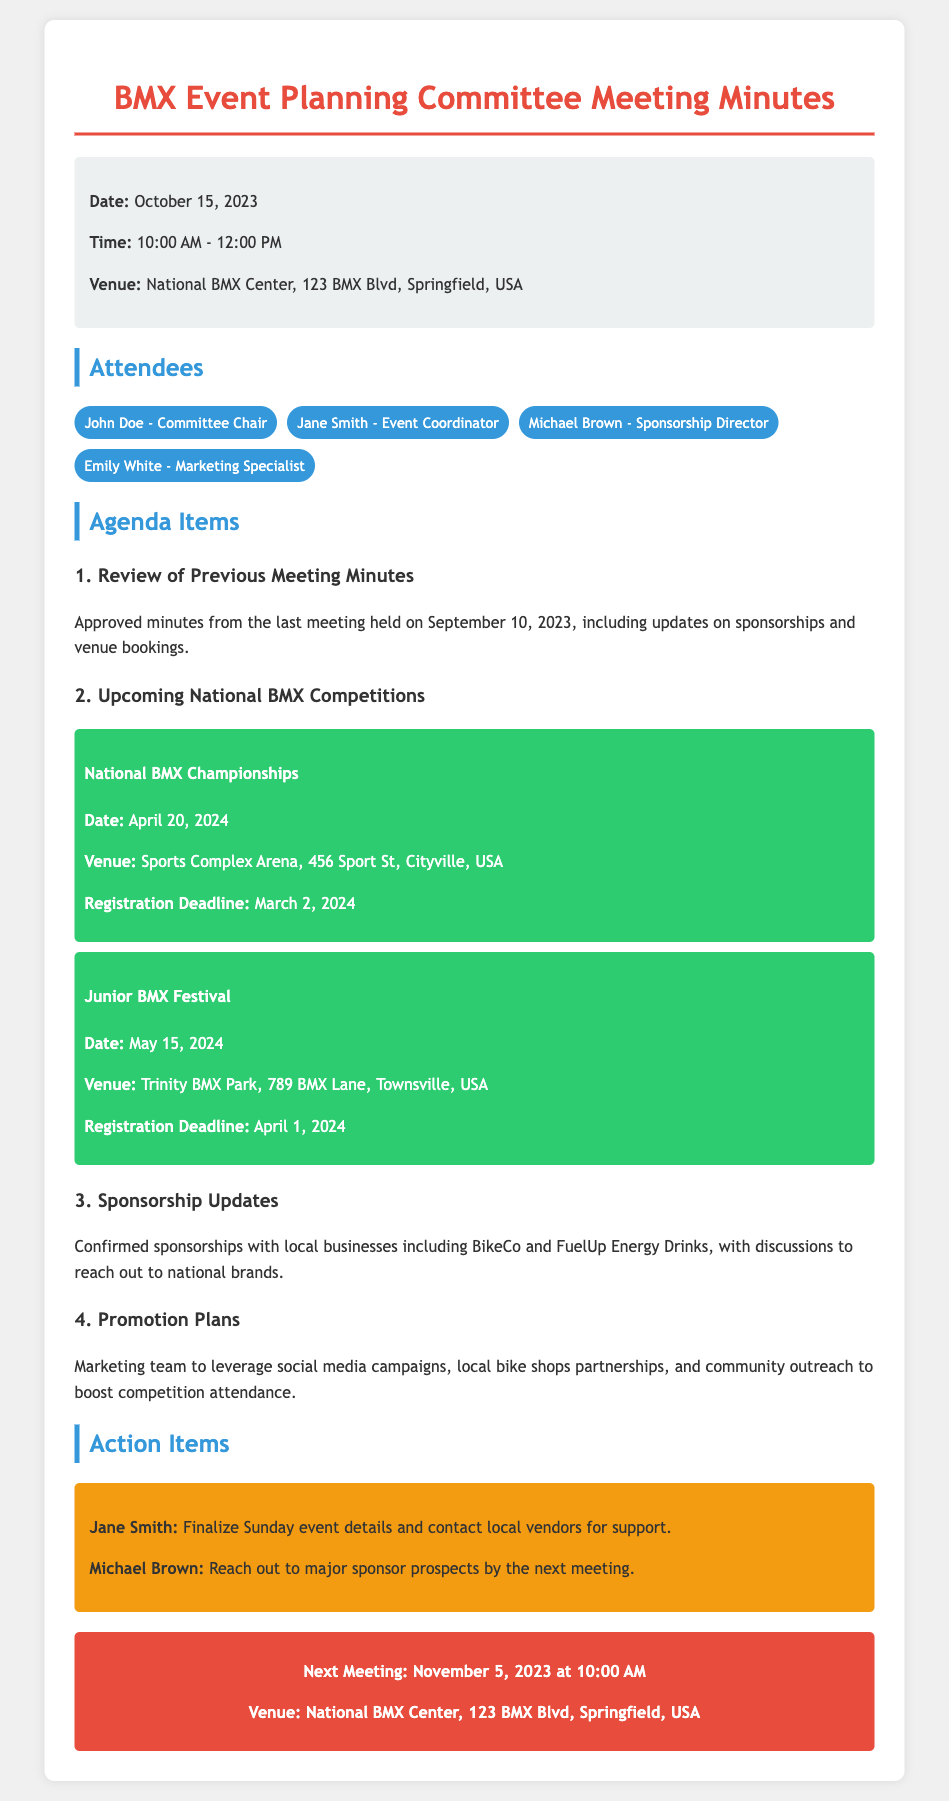what is the date of the next meeting? The next meeting date is listed under the next meeting section of the document.
Answer: November 5, 2023 where is the National BMX Championships held? The venue for the National BMX Championships is mentioned under the upcoming national BMX competitions section.
Answer: Sports Complex Arena, 456 Sport St, Cityville, USA who is the Committee Chair? The name of the Committee Chair is provided in the attendees section of the document.
Answer: John Doe what is the registration deadline for the Junior BMX Festival? The registration deadline is provided in the details of the Junior BMX Festival under the upcoming competitions.
Answer: April 1, 2024 how many attendees were present at the meeting? The number of attendees can be counted from the attendees section where their names are listed.
Answer: 4 what is one of the action items assigned to Michael Brown? The action items section outlines specific tasks assigned to members, including Michael Brown.
Answer: Reach out to major sponsor prospects by the next meeting what should the marketing team focus on for promotion? The promotion plans are detailed in one of the agenda items discussing strategies for increasing attendance.
Answer: Social media campaigns, local bike shops partnerships, and community outreach 